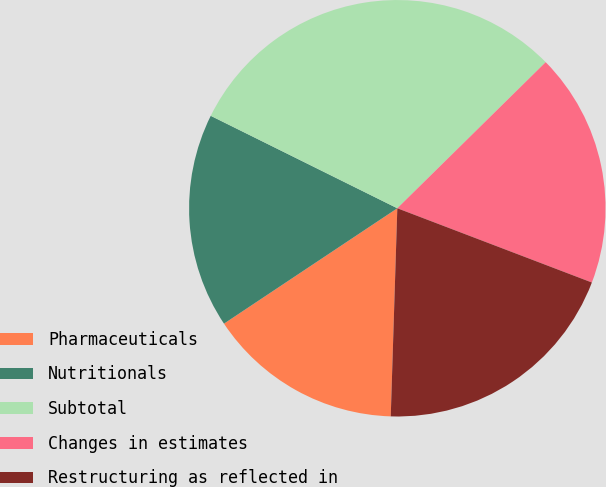<chart> <loc_0><loc_0><loc_500><loc_500><pie_chart><fcel>Pharmaceuticals<fcel>Nutritionals<fcel>Subtotal<fcel>Changes in estimates<fcel>Restructuring as reflected in<nl><fcel>15.15%<fcel>16.67%<fcel>30.3%<fcel>18.18%<fcel>19.7%<nl></chart> 